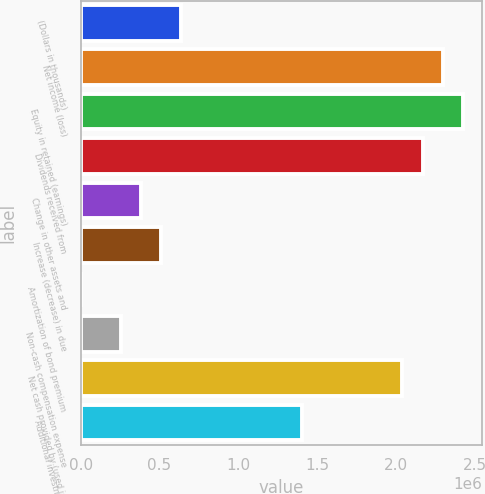Convert chart. <chart><loc_0><loc_0><loc_500><loc_500><bar_chart><fcel>(Dollars in thousands)<fcel>Net income (loss)<fcel>Equity in retained (earnings)<fcel>Dividends received from<fcel>Change in other assets and<fcel>Increase (decrease) in due<fcel>Amortization of bond premium<fcel>Non-cash compensation expense<fcel>Net cash provided by (used in)<fcel>Additional investment in<nl><fcel>638098<fcel>2.29653e+06<fcel>2.4241e+06<fcel>2.16895e+06<fcel>382955<fcel>510527<fcel>241<fcel>255384<fcel>2.04138e+06<fcel>1.40353e+06<nl></chart> 